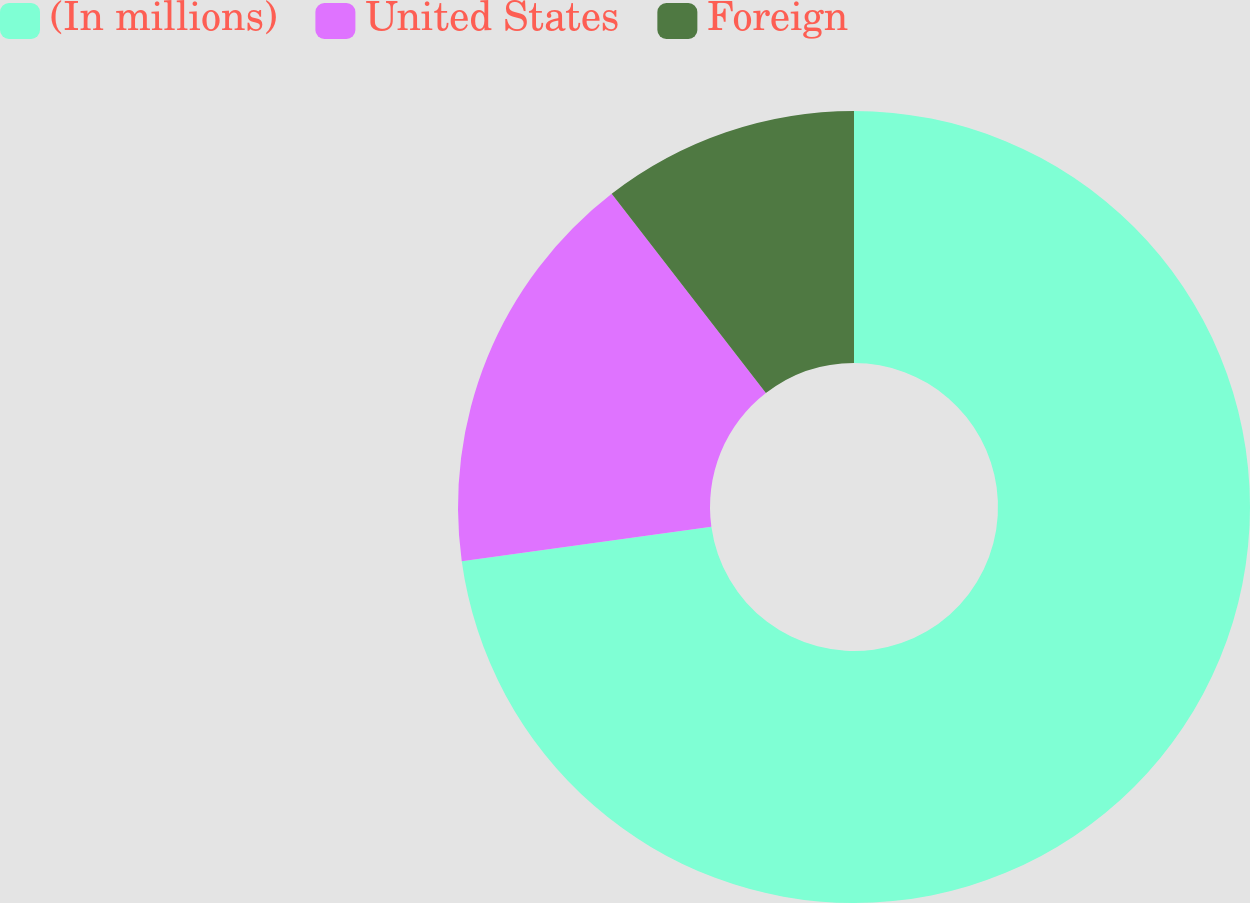Convert chart. <chart><loc_0><loc_0><loc_500><loc_500><pie_chart><fcel>(In millions)<fcel>United States<fcel>Foreign<nl><fcel>72.81%<fcel>16.71%<fcel>10.48%<nl></chart> 